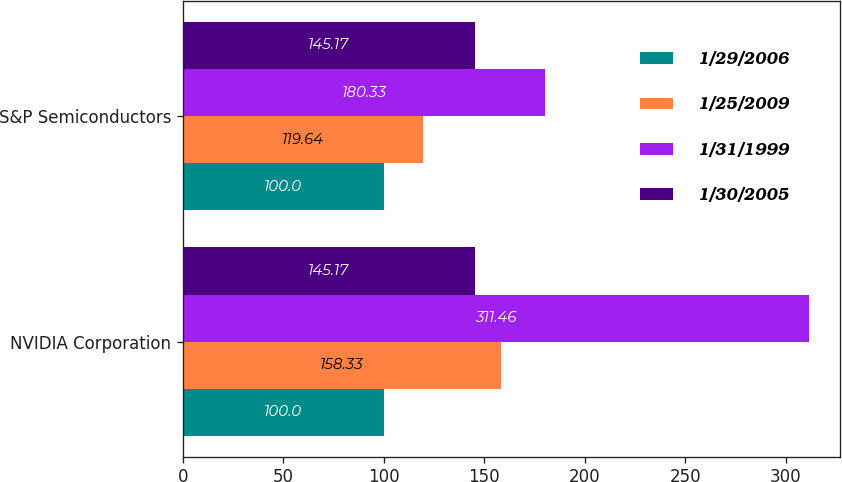Convert chart to OTSL. <chart><loc_0><loc_0><loc_500><loc_500><stacked_bar_chart><ecel><fcel>NVIDIA Corporation<fcel>S&P Semiconductors<nl><fcel>1/29/2006<fcel>100<fcel>100<nl><fcel>1/25/2009<fcel>158.33<fcel>119.64<nl><fcel>1/31/1999<fcel>311.46<fcel>180.33<nl><fcel>1/30/2005<fcel>145.17<fcel>145.17<nl></chart> 